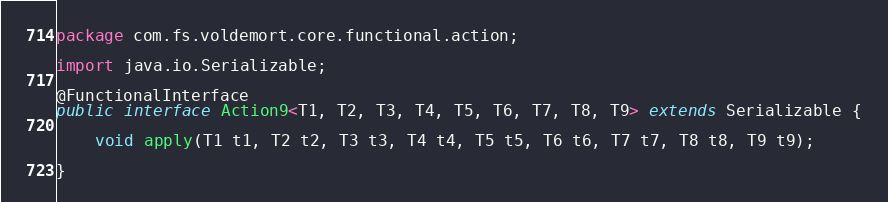<code> <loc_0><loc_0><loc_500><loc_500><_Java_>package com.fs.voldemort.core.functional.action;

import java.io.Serializable;

@FunctionalInterface
public interface Action9<T1, T2, T3, T4, T5, T6, T7, T8, T9> extends Serializable {

    void apply(T1 t1, T2 t2, T3 t3, T4 t4, T5 t5, T6 t6, T7 t7, T8 t8, T9 t9);
    
}
</code> 